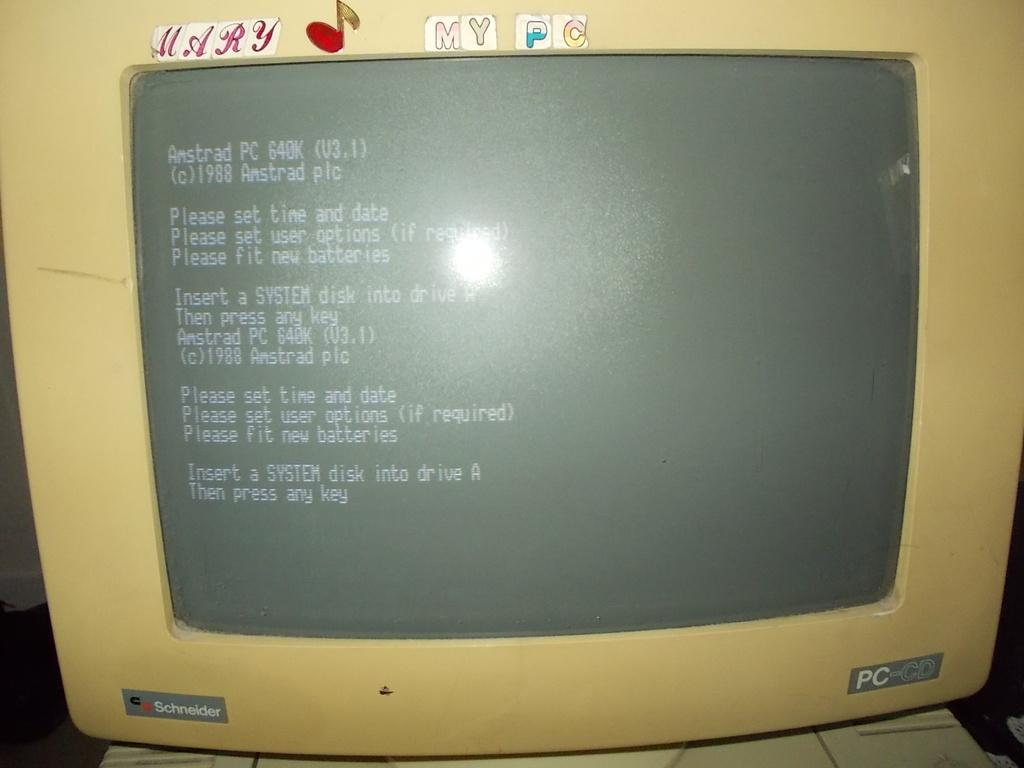What kind of disk should be inserted in drive a?
Your answer should be very brief. System. What brand of computer is this?
Make the answer very short. Schneider. 